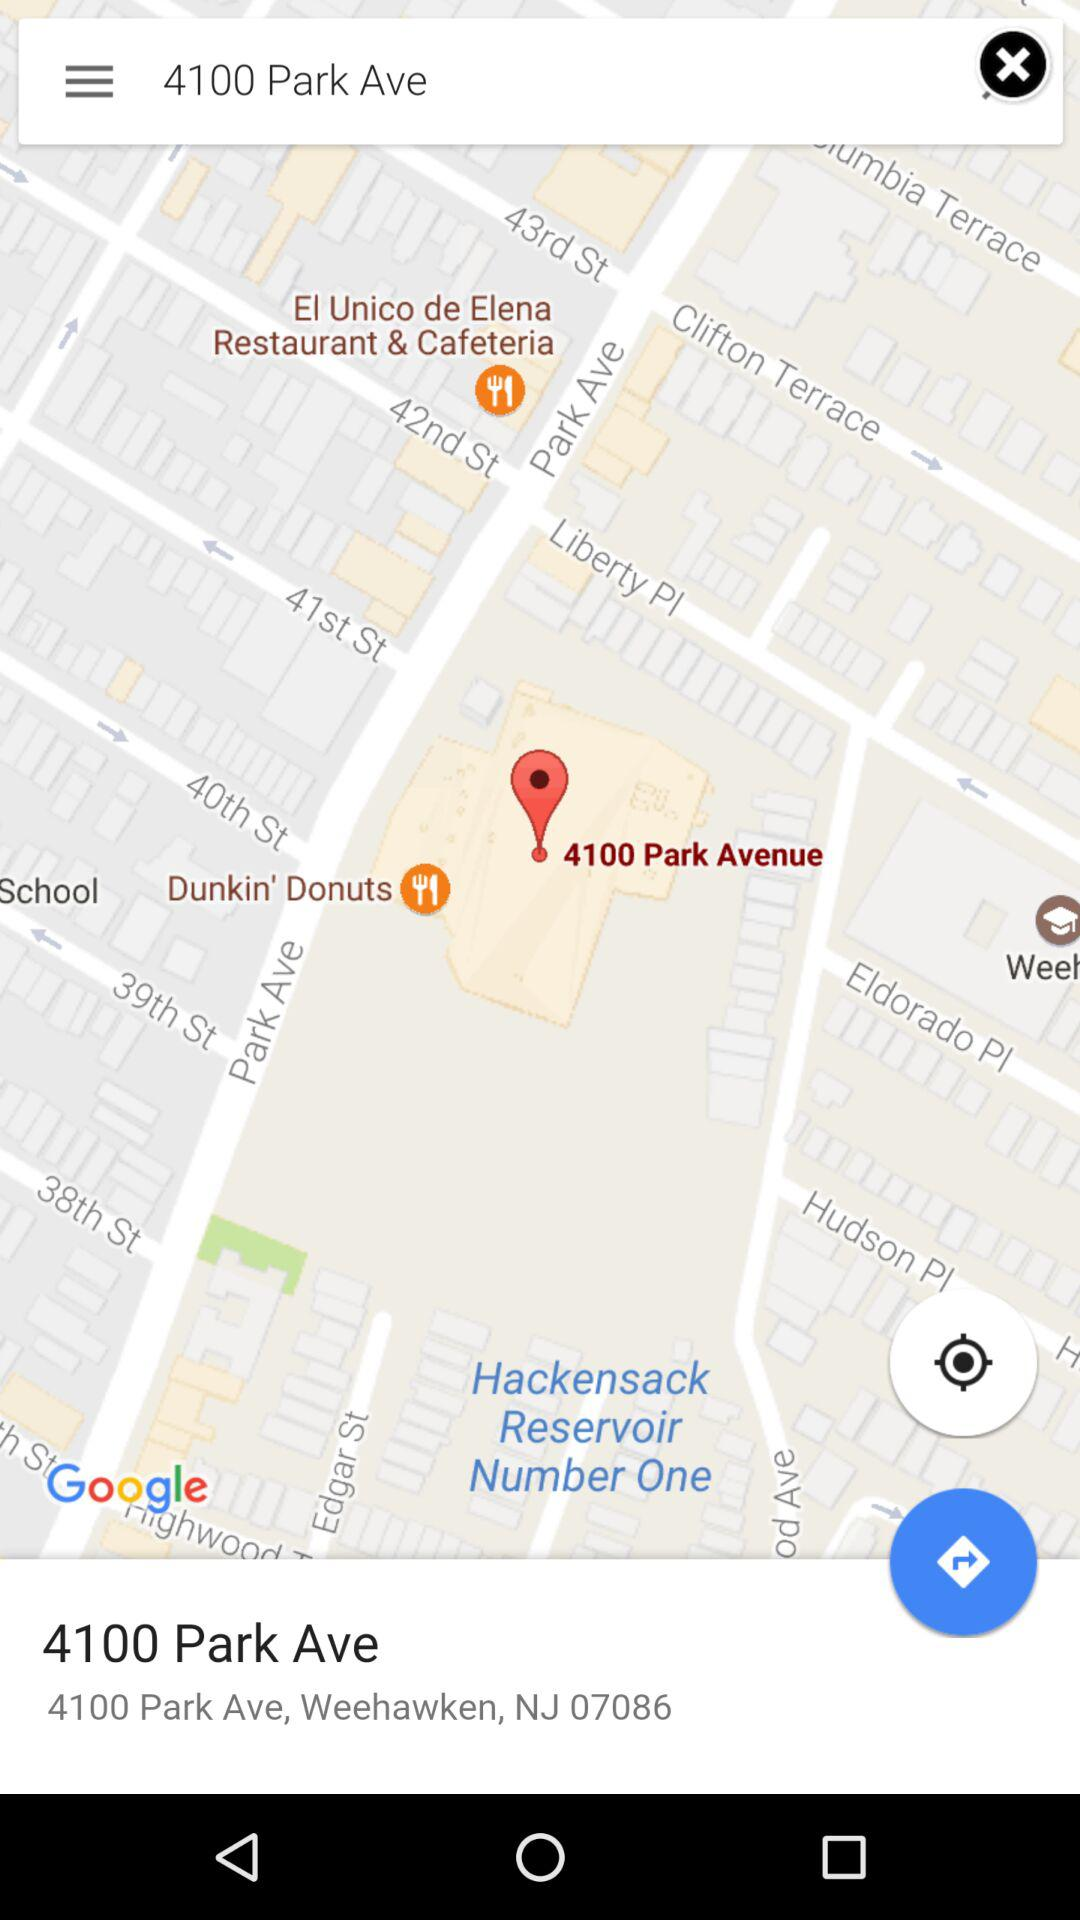How far away is 4100 Park Avenue?
When the provided information is insufficient, respond with <no answer>. <no answer> 